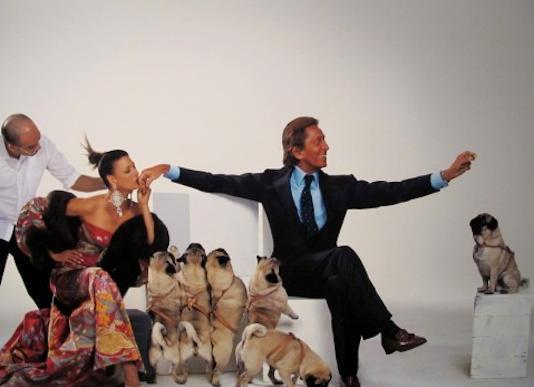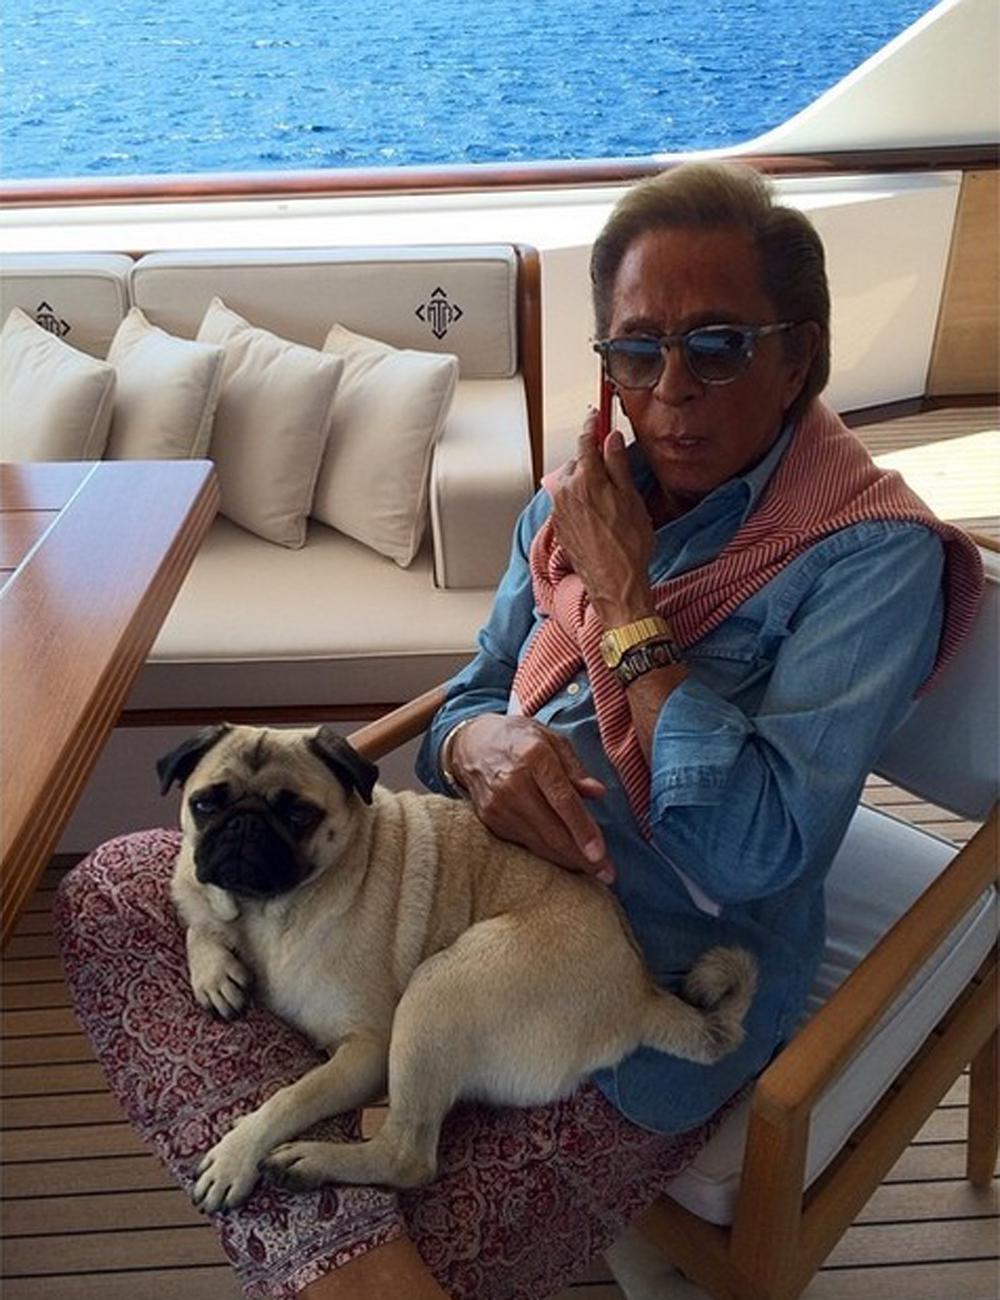The first image is the image on the left, the second image is the image on the right. Assess this claim about the two images: "One of the images shows only one dog and one man.". Correct or not? Answer yes or no. Yes. The first image is the image on the left, the second image is the image on the right. Considering the images on both sides, is "The right image contains no more than one dog." valid? Answer yes or no. Yes. 